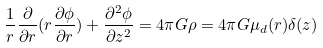<formula> <loc_0><loc_0><loc_500><loc_500>\frac { 1 } { r } \frac { \partial } { \partial r } ( r \frac { \partial \phi } { \partial r } ) + \frac { \partial ^ { 2 } \phi } { \partial z ^ { 2 } } = 4 \pi G \rho = 4 \pi G \mu _ { d } ( r ) \delta ( z )</formula> 